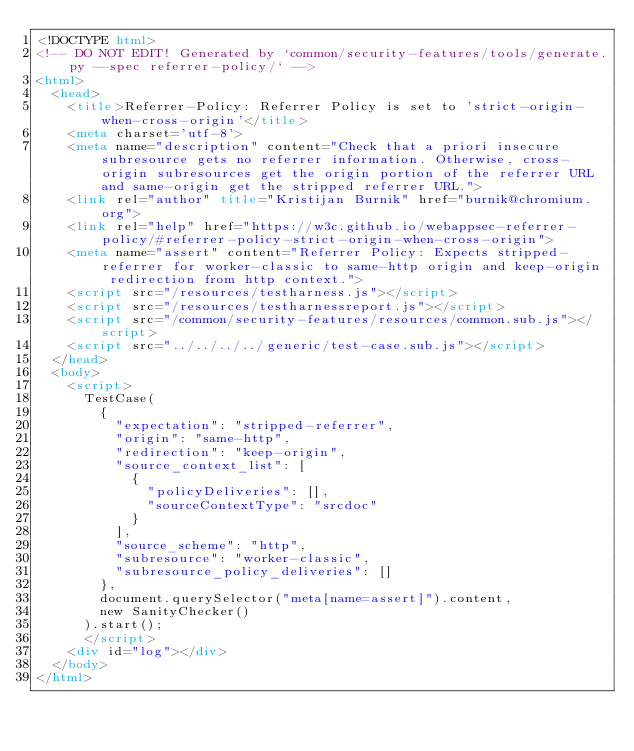Convert code to text. <code><loc_0><loc_0><loc_500><loc_500><_HTML_><!DOCTYPE html>
<!-- DO NOT EDIT! Generated by `common/security-features/tools/generate.py --spec referrer-policy/` -->
<html>
  <head>
    <title>Referrer-Policy: Referrer Policy is set to 'strict-origin-when-cross-origin'</title>
    <meta charset='utf-8'>
    <meta name="description" content="Check that a priori insecure subresource gets no referrer information. Otherwise, cross-origin subresources get the origin portion of the referrer URL and same-origin get the stripped referrer URL.">
    <link rel="author" title="Kristijan Burnik" href="burnik@chromium.org">
    <link rel="help" href="https://w3c.github.io/webappsec-referrer-policy/#referrer-policy-strict-origin-when-cross-origin">
    <meta name="assert" content="Referrer Policy: Expects stripped-referrer for worker-classic to same-http origin and keep-origin redirection from http context.">
    <script src="/resources/testharness.js"></script>
    <script src="/resources/testharnessreport.js"></script>
    <script src="/common/security-features/resources/common.sub.js"></script>
    <script src="../../../../generic/test-case.sub.js"></script>
  </head>
  <body>
    <script>
      TestCase(
        {
          "expectation": "stripped-referrer",
          "origin": "same-http",
          "redirection": "keep-origin",
          "source_context_list": [
            {
              "policyDeliveries": [],
              "sourceContextType": "srcdoc"
            }
          ],
          "source_scheme": "http",
          "subresource": "worker-classic",
          "subresource_policy_deliveries": []
        },
        document.querySelector("meta[name=assert]").content,
        new SanityChecker()
      ).start();
      </script>
    <div id="log"></div>
  </body>
</html>
</code> 